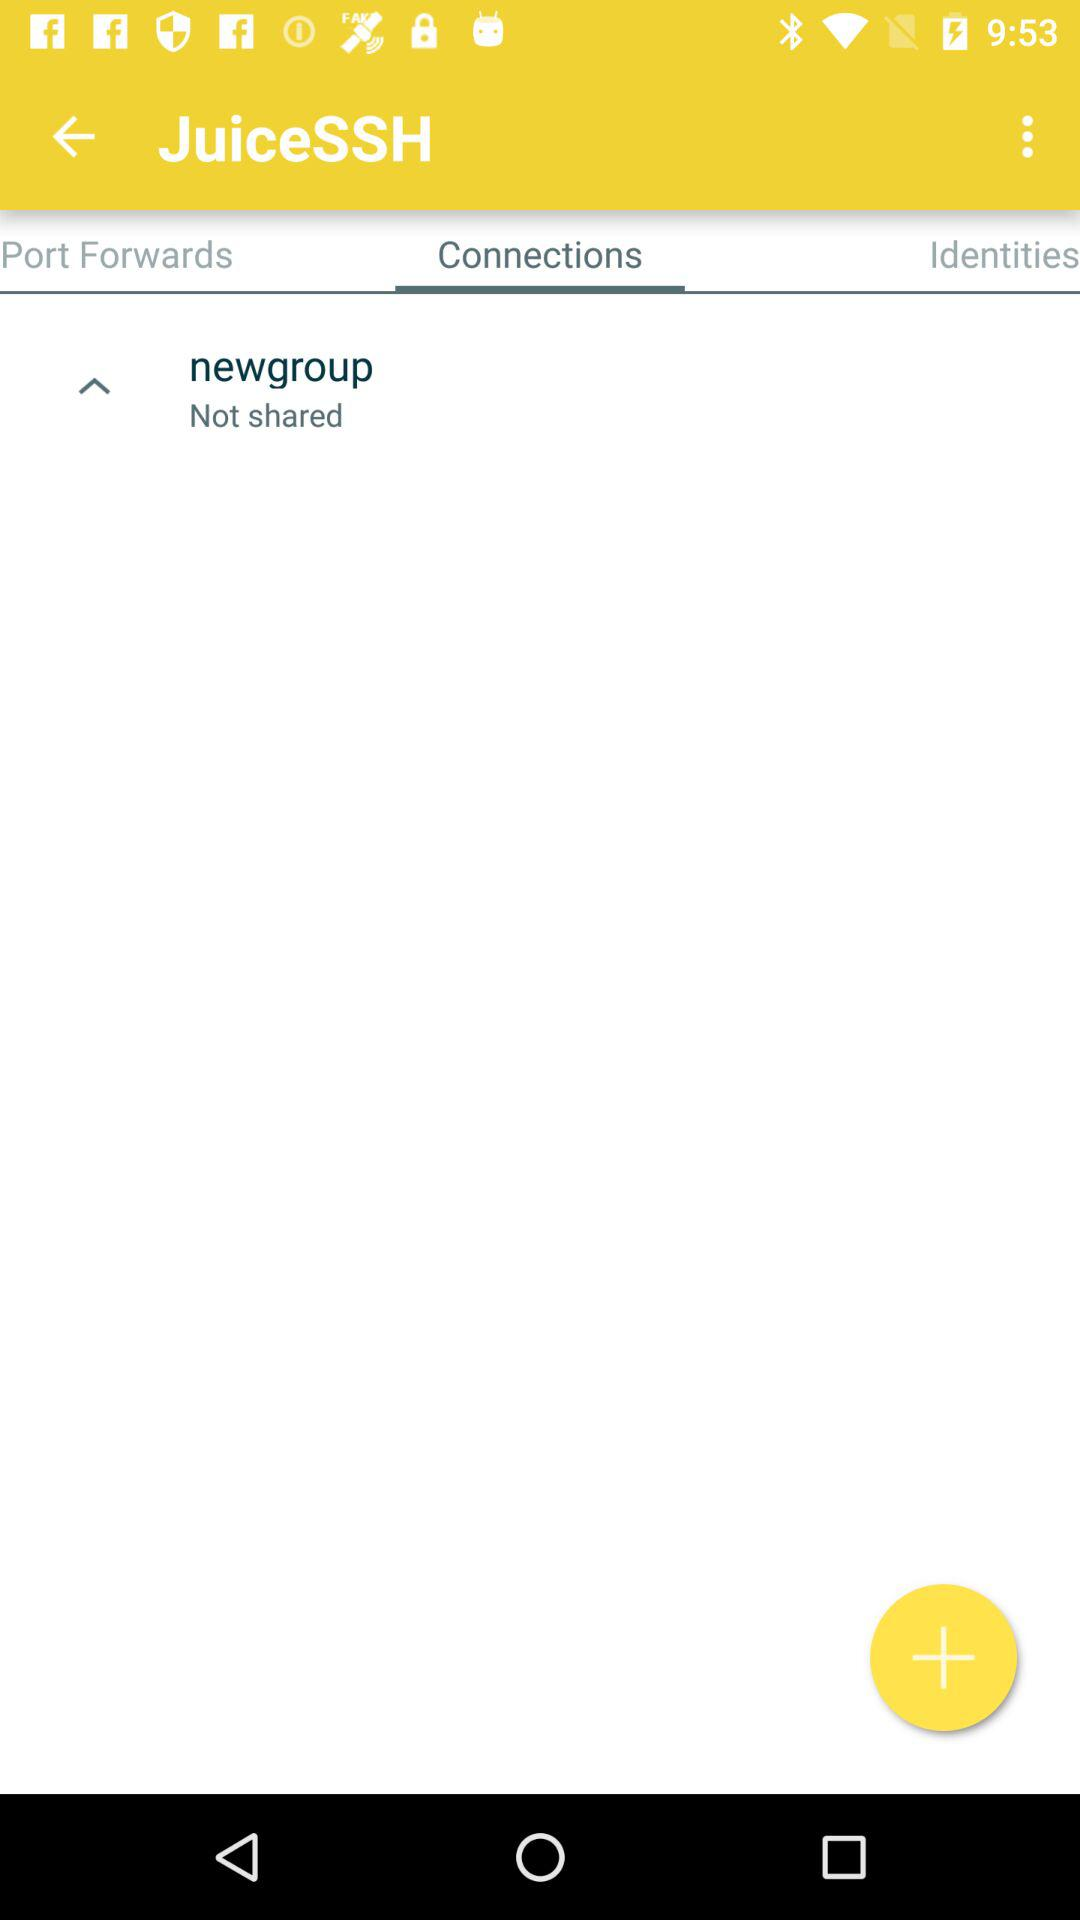What is the selected tab? The selected tab is "Connections". 